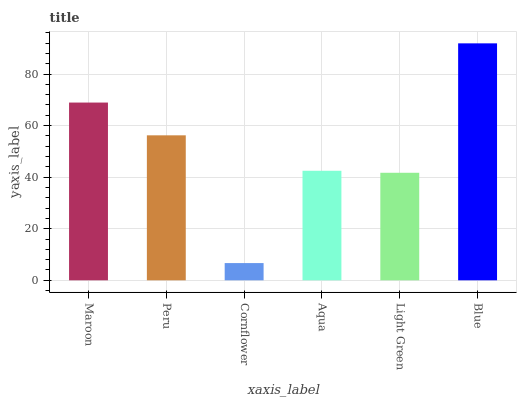Is Peru the minimum?
Answer yes or no. No. Is Peru the maximum?
Answer yes or no. No. Is Maroon greater than Peru?
Answer yes or no. Yes. Is Peru less than Maroon?
Answer yes or no. Yes. Is Peru greater than Maroon?
Answer yes or no. No. Is Maroon less than Peru?
Answer yes or no. No. Is Peru the high median?
Answer yes or no. Yes. Is Aqua the low median?
Answer yes or no. Yes. Is Cornflower the high median?
Answer yes or no. No. Is Maroon the low median?
Answer yes or no. No. 